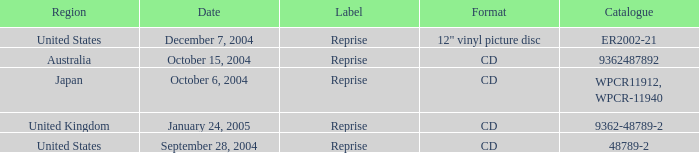What is the directory on october 15, 2004? 9362487892.0. 